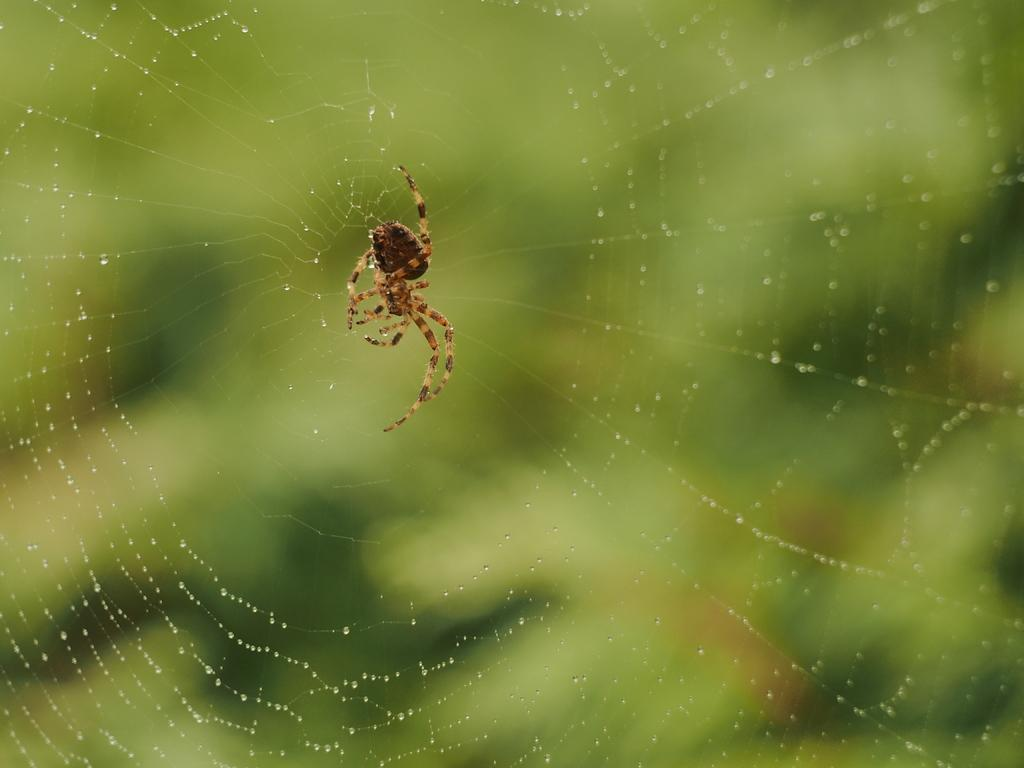What is the main subject of the image? The main subject of the image is a spider. Where is the spider located in the image? The spider is on a spider web. Can you describe the background of the image? The background of the image is blurred. What type of attack is the spider planning in the image? There is no indication in the image that the spider is planning an attack. 